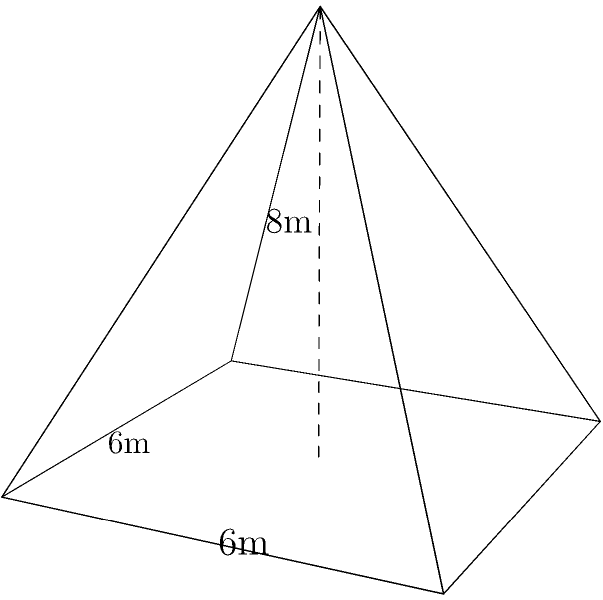In your magical rainforest, you've decided to build a treehouse for your animal friends. The treehouse is shaped like a pyramid with a square base. If the side length of the base is 6 meters and the height of the pyramid is 8 meters, what is the volume of your treehouse in cubic meters? Let's solve this step-by-step:

1) The formula for the volume of a pyramid is:
   $$ V = \frac{1}{3} \times B \times h $$
   where $V$ is the volume, $B$ is the area of the base, and $h$ is the height.

2) We know the height $h = 8$ meters.

3) The base is a square with side length 6 meters. So the area of the base is:
   $$ B = 6 \times 6 = 36 \text{ square meters} $$

4) Now we can plug these values into our formula:
   $$ V = \frac{1}{3} \times 36 \times 8 $$

5) Let's calculate:
   $$ V = \frac{1}{3} \times 288 = 96 \text{ cubic meters} $$

Therefore, the volume of your pyramidal treehouse is 96 cubic meters.
Answer: 96 cubic meters 